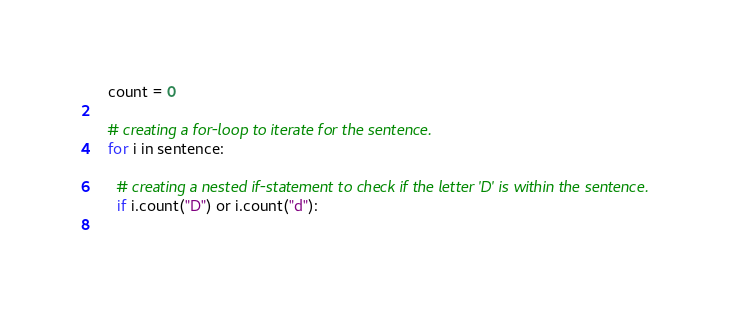<code> <loc_0><loc_0><loc_500><loc_500><_Python_>  count = 0
  
  # creating a for-loop to iterate for the sentence.
  for i in sentence:
    
    # creating a nested if-statement to check if the letter 'D' is within the sentence.
    if i.count("D") or i.count("d"):
      </code> 